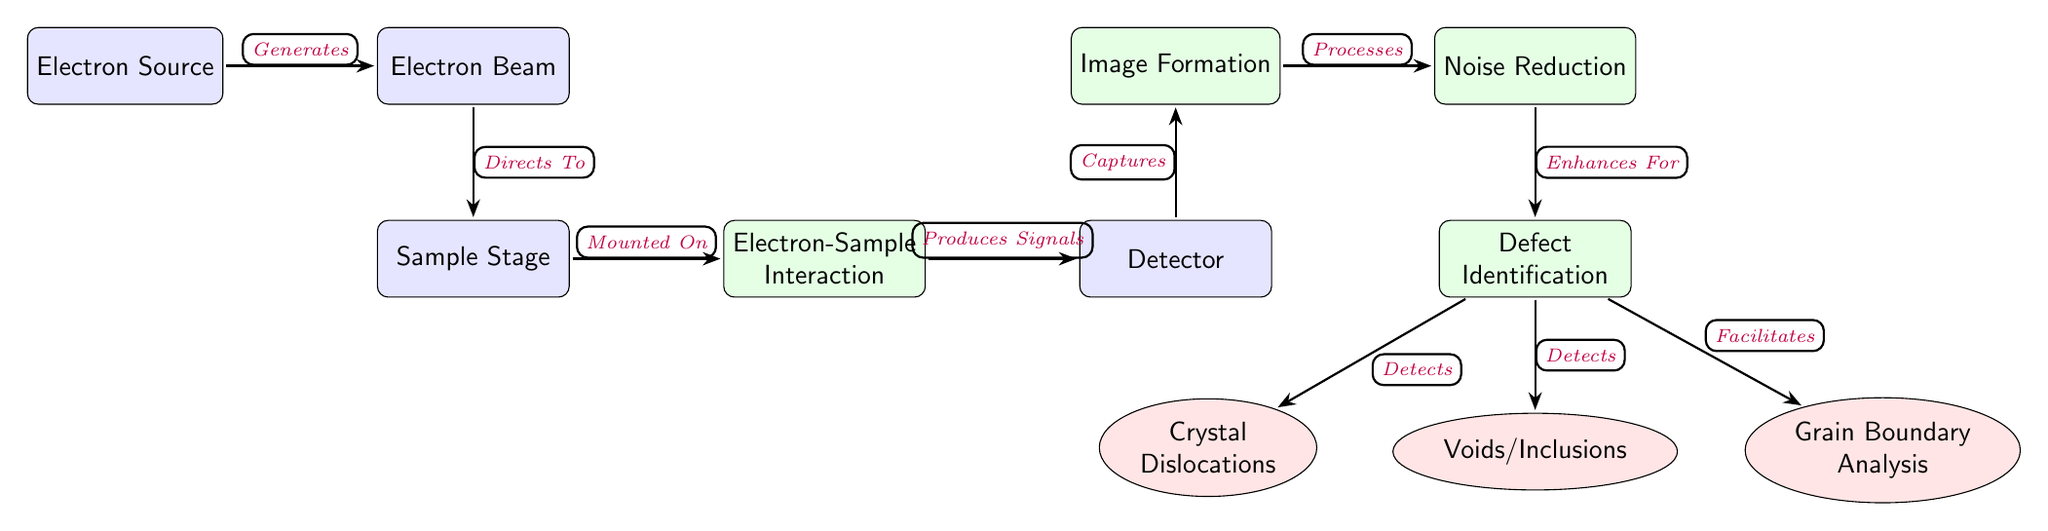What is the first node in the diagram? The first node in the diagram is labeled "Electron Source," which is where the process begins.
Answer: Electron Source How many result nodes are present in the diagram? There are three result nodes in the diagram: "Crystal Dislocations," "Voids/Inclusions," and "Grain Boundary Analysis."
Answer: 3 What does the "Detector" node receive signals from? The "Detector" node receives signals produced from the "Electron-Sample Interaction" node, showing a direct relationship in the flow of the process.
Answer: Electron-Sample Interaction Which node is directly connected to "Noise Reduction"? The "Defect Identification" node is directly connected to the "Noise Reduction" node, indicating that their processes are sequential and interconnected.
Answer: Defect Identification What is the last step in the diagram before identifying defects? The last step before identifying defects is "Noise Reduction," which indicates the process of enhancing the signals prior to defect identification.
Answer: Noise Reduction What type of analysis does the "Defect Identification" node facilitate? The "Defect Identification" node facilitates "Grain Boundary Analysis," shown by the directional edge indicating a relationship between these nodes.
Answer: Grain Boundary Analysis Which node generates the electron beam? The "Electron Source" is indicated as responsible for generating the electron beam, marking the starting point of the entire process.
Answer: Electron Beam What type of relationship exists between "Electron Beam" and "Sample Stage"? The relationship between "Electron Beam" and "Sample Stage" is described as "Directs To," indicating the flow of the process directs the beam towards the sample stage for analysis.
Answer: Directs To What are the specific types of defects detected in the diagram? The specific types of defects detected in the diagram include "Crystal Dislocations," "Voids/Inclusions," and "Grain Boundary Analysis," showcasing the outcomes of the defect identification process.
Answer: Crystal Dislocations, Voids/Inclusions, Grain Boundary Analysis 